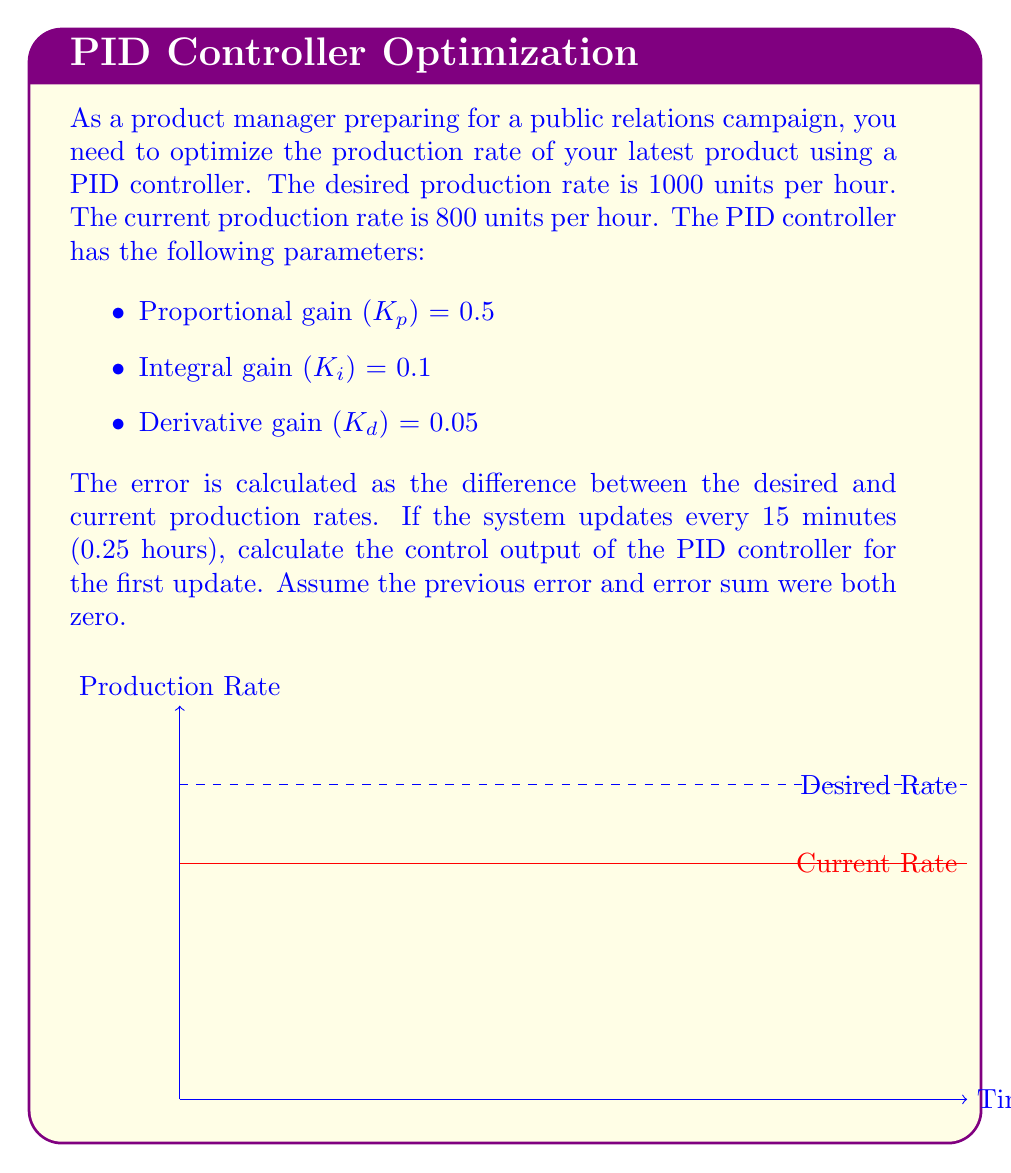Can you answer this question? Let's break this down step-by-step:

1) First, calculate the error:
   $e = \text{Desired Rate} - \text{Current Rate}$
   $e = 1000 - 800 = 200$ units/hour

2) The PID controller equation is:
   $$u(t) = K_p e(t) + K_i \int e(t) dt + K_d \frac{de(t)}{dt}$$

3) For the discrete form with a time step of Δt:
   $$u(k) = K_p e(k) + K_i \sum_{i=0}^k e(i) \Delta t + K_d \frac{e(k) - e(k-1)}{\Delta t}$$

4) We're calculating for the first update, so:
   - $e(k) = 200$
   - $\sum_{i=0}^k e(i) = 200$ (only current error)
   - $e(k) - e(k-1) = 200 - 0 = 200$ (previous error was 0)
   - $\Delta t = 0.25$ hours

5) Now, let's substitute these values:
   $$u(1) = 0.5 * 200 + 0.1 * 200 * 0.25 + 0.05 * \frac{200}{0.25}$$

6) Calculate each term:
   - Proportional term: $0.5 * 200 = 100$
   - Integral term: $0.1 * 200 * 0.25 = 5$
   - Derivative term: $0.05 * \frac{200}{0.25} = 40$

7) Sum up all terms:
   $$u(1) = 100 + 5 + 40 = 145$$

This means the PID controller suggests increasing the production rate by 145 units/hour.
Answer: 145 units/hour 